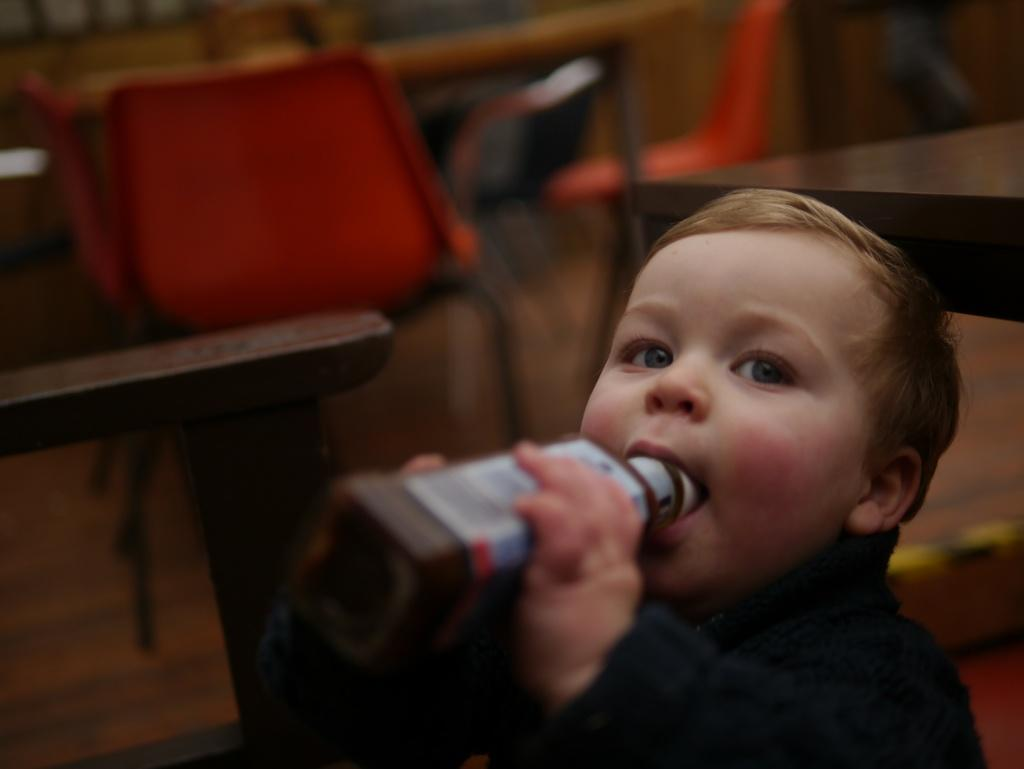Who is the main subject in the image? There is a boy in the image. What is the boy wearing? The boy is wearing a dark blue sweatshirt. What is the boy holding in the image? The boy is holding a bottle. What can be seen in the background of the image? There are orange color chairs and tables in the background. Can you see any vases in the image? There is no vase present in the image. Is there any steam coming from the bottle the boy is holding? The image does not show any steam coming from the bottle. 